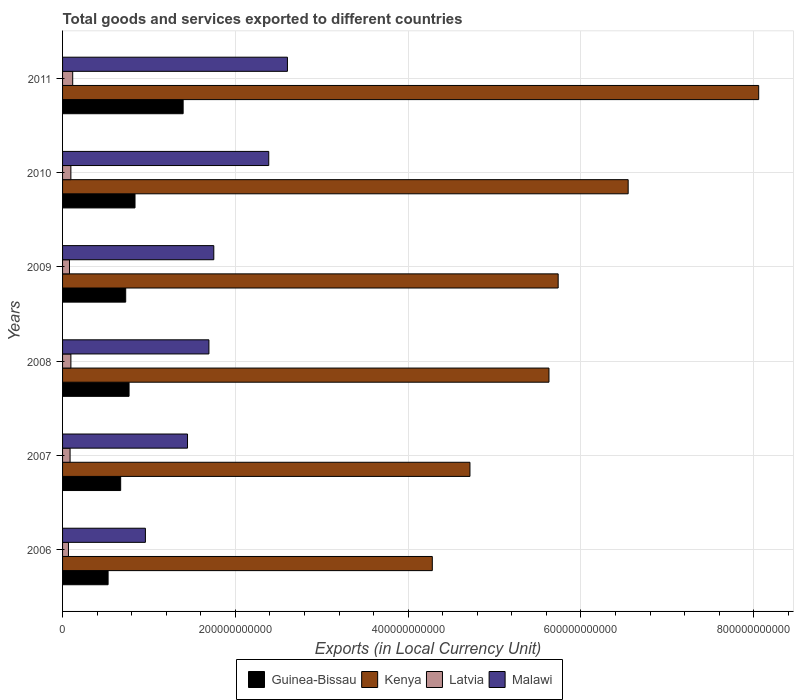How many different coloured bars are there?
Offer a very short reply. 4. Are the number of bars per tick equal to the number of legend labels?
Offer a very short reply. Yes. What is the label of the 1st group of bars from the top?
Your answer should be very brief. 2011. In how many cases, is the number of bars for a given year not equal to the number of legend labels?
Your response must be concise. 0. What is the Amount of goods and services exports in Latvia in 2006?
Offer a very short reply. 6.84e+09. Across all years, what is the maximum Amount of goods and services exports in Kenya?
Ensure brevity in your answer.  8.06e+11. Across all years, what is the minimum Amount of goods and services exports in Kenya?
Give a very brief answer. 4.28e+11. In which year was the Amount of goods and services exports in Latvia maximum?
Offer a terse response. 2011. In which year was the Amount of goods and services exports in Guinea-Bissau minimum?
Make the answer very short. 2006. What is the total Amount of goods and services exports in Kenya in the graph?
Keep it short and to the point. 3.50e+12. What is the difference between the Amount of goods and services exports in Latvia in 2007 and that in 2009?
Provide a succinct answer. 6.66e+08. What is the difference between the Amount of goods and services exports in Malawi in 2006 and the Amount of goods and services exports in Kenya in 2009?
Make the answer very short. -4.78e+11. What is the average Amount of goods and services exports in Malawi per year?
Offer a very short reply. 1.81e+11. In the year 2011, what is the difference between the Amount of goods and services exports in Guinea-Bissau and Amount of goods and services exports in Latvia?
Provide a short and direct response. 1.28e+11. In how many years, is the Amount of goods and services exports in Guinea-Bissau greater than 760000000000 LCU?
Offer a very short reply. 0. What is the ratio of the Amount of goods and services exports in Malawi in 2006 to that in 2011?
Keep it short and to the point. 0.37. Is the Amount of goods and services exports in Malawi in 2007 less than that in 2010?
Your answer should be very brief. Yes. Is the difference between the Amount of goods and services exports in Guinea-Bissau in 2007 and 2009 greater than the difference between the Amount of goods and services exports in Latvia in 2007 and 2009?
Your answer should be compact. No. What is the difference between the highest and the second highest Amount of goods and services exports in Guinea-Bissau?
Provide a short and direct response. 5.57e+1. What is the difference between the highest and the lowest Amount of goods and services exports in Malawi?
Your response must be concise. 1.64e+11. Is the sum of the Amount of goods and services exports in Kenya in 2007 and 2011 greater than the maximum Amount of goods and services exports in Latvia across all years?
Offer a terse response. Yes. What does the 1st bar from the top in 2009 represents?
Provide a succinct answer. Malawi. What does the 3rd bar from the bottom in 2007 represents?
Give a very brief answer. Latvia. Is it the case that in every year, the sum of the Amount of goods and services exports in Malawi and Amount of goods and services exports in Guinea-Bissau is greater than the Amount of goods and services exports in Kenya?
Your answer should be compact. No. Are all the bars in the graph horizontal?
Make the answer very short. Yes. How many years are there in the graph?
Your answer should be compact. 6. What is the difference between two consecutive major ticks on the X-axis?
Make the answer very short. 2.00e+11. Are the values on the major ticks of X-axis written in scientific E-notation?
Keep it short and to the point. No. Where does the legend appear in the graph?
Offer a terse response. Bottom center. How many legend labels are there?
Your answer should be very brief. 4. What is the title of the graph?
Ensure brevity in your answer.  Total goods and services exported to different countries. Does "Pakistan" appear as one of the legend labels in the graph?
Your answer should be compact. No. What is the label or title of the X-axis?
Provide a succinct answer. Exports (in Local Currency Unit). What is the Exports (in Local Currency Unit) in Guinea-Bissau in 2006?
Your answer should be compact. 5.27e+1. What is the Exports (in Local Currency Unit) of Kenya in 2006?
Ensure brevity in your answer.  4.28e+11. What is the Exports (in Local Currency Unit) of Latvia in 2006?
Keep it short and to the point. 6.84e+09. What is the Exports (in Local Currency Unit) of Malawi in 2006?
Ensure brevity in your answer.  9.59e+1. What is the Exports (in Local Currency Unit) in Guinea-Bissau in 2007?
Offer a very short reply. 6.73e+1. What is the Exports (in Local Currency Unit) of Kenya in 2007?
Your answer should be compact. 4.72e+11. What is the Exports (in Local Currency Unit) of Latvia in 2007?
Your answer should be very brief. 8.69e+09. What is the Exports (in Local Currency Unit) of Malawi in 2007?
Your response must be concise. 1.45e+11. What is the Exports (in Local Currency Unit) of Guinea-Bissau in 2008?
Make the answer very short. 7.70e+1. What is the Exports (in Local Currency Unit) in Kenya in 2008?
Provide a succinct answer. 5.63e+11. What is the Exports (in Local Currency Unit) of Latvia in 2008?
Make the answer very short. 9.63e+09. What is the Exports (in Local Currency Unit) in Malawi in 2008?
Ensure brevity in your answer.  1.69e+11. What is the Exports (in Local Currency Unit) in Guinea-Bissau in 2009?
Your answer should be compact. 7.31e+1. What is the Exports (in Local Currency Unit) in Kenya in 2009?
Your response must be concise. 5.74e+11. What is the Exports (in Local Currency Unit) of Latvia in 2009?
Your response must be concise. 8.02e+09. What is the Exports (in Local Currency Unit) in Malawi in 2009?
Offer a terse response. 1.75e+11. What is the Exports (in Local Currency Unit) in Guinea-Bissau in 2010?
Your response must be concise. 8.39e+1. What is the Exports (in Local Currency Unit) of Kenya in 2010?
Keep it short and to the point. 6.55e+11. What is the Exports (in Local Currency Unit) in Latvia in 2010?
Offer a very short reply. 9.62e+09. What is the Exports (in Local Currency Unit) in Malawi in 2010?
Offer a very short reply. 2.39e+11. What is the Exports (in Local Currency Unit) in Guinea-Bissau in 2011?
Offer a very short reply. 1.40e+11. What is the Exports (in Local Currency Unit) in Kenya in 2011?
Your answer should be compact. 8.06e+11. What is the Exports (in Local Currency Unit) of Latvia in 2011?
Make the answer very short. 1.17e+1. What is the Exports (in Local Currency Unit) in Malawi in 2011?
Make the answer very short. 2.60e+11. Across all years, what is the maximum Exports (in Local Currency Unit) in Guinea-Bissau?
Provide a short and direct response. 1.40e+11. Across all years, what is the maximum Exports (in Local Currency Unit) in Kenya?
Keep it short and to the point. 8.06e+11. Across all years, what is the maximum Exports (in Local Currency Unit) in Latvia?
Give a very brief answer. 1.17e+1. Across all years, what is the maximum Exports (in Local Currency Unit) of Malawi?
Your answer should be very brief. 2.60e+11. Across all years, what is the minimum Exports (in Local Currency Unit) in Guinea-Bissau?
Keep it short and to the point. 5.27e+1. Across all years, what is the minimum Exports (in Local Currency Unit) of Kenya?
Provide a short and direct response. 4.28e+11. Across all years, what is the minimum Exports (in Local Currency Unit) of Latvia?
Provide a short and direct response. 6.84e+09. Across all years, what is the minimum Exports (in Local Currency Unit) in Malawi?
Offer a terse response. 9.59e+1. What is the total Exports (in Local Currency Unit) of Guinea-Bissau in the graph?
Your answer should be compact. 4.93e+11. What is the total Exports (in Local Currency Unit) in Kenya in the graph?
Your answer should be compact. 3.50e+12. What is the total Exports (in Local Currency Unit) in Latvia in the graph?
Your answer should be very brief. 5.45e+1. What is the total Exports (in Local Currency Unit) of Malawi in the graph?
Keep it short and to the point. 1.08e+12. What is the difference between the Exports (in Local Currency Unit) of Guinea-Bissau in 2006 and that in 2007?
Your answer should be very brief. -1.46e+1. What is the difference between the Exports (in Local Currency Unit) of Kenya in 2006 and that in 2007?
Ensure brevity in your answer.  -4.36e+1. What is the difference between the Exports (in Local Currency Unit) of Latvia in 2006 and that in 2007?
Provide a succinct answer. -1.85e+09. What is the difference between the Exports (in Local Currency Unit) in Malawi in 2006 and that in 2007?
Your response must be concise. -4.87e+1. What is the difference between the Exports (in Local Currency Unit) of Guinea-Bissau in 2006 and that in 2008?
Provide a succinct answer. -2.43e+1. What is the difference between the Exports (in Local Currency Unit) of Kenya in 2006 and that in 2008?
Provide a succinct answer. -1.35e+11. What is the difference between the Exports (in Local Currency Unit) of Latvia in 2006 and that in 2008?
Your answer should be compact. -2.79e+09. What is the difference between the Exports (in Local Currency Unit) in Malawi in 2006 and that in 2008?
Keep it short and to the point. -7.35e+1. What is the difference between the Exports (in Local Currency Unit) in Guinea-Bissau in 2006 and that in 2009?
Your answer should be very brief. -2.04e+1. What is the difference between the Exports (in Local Currency Unit) of Kenya in 2006 and that in 2009?
Offer a very short reply. -1.46e+11. What is the difference between the Exports (in Local Currency Unit) of Latvia in 2006 and that in 2009?
Provide a succinct answer. -1.18e+09. What is the difference between the Exports (in Local Currency Unit) in Malawi in 2006 and that in 2009?
Offer a terse response. -7.92e+1. What is the difference between the Exports (in Local Currency Unit) of Guinea-Bissau in 2006 and that in 2010?
Offer a terse response. -3.12e+1. What is the difference between the Exports (in Local Currency Unit) in Kenya in 2006 and that in 2010?
Keep it short and to the point. -2.27e+11. What is the difference between the Exports (in Local Currency Unit) in Latvia in 2006 and that in 2010?
Offer a terse response. -2.79e+09. What is the difference between the Exports (in Local Currency Unit) of Malawi in 2006 and that in 2010?
Provide a succinct answer. -1.43e+11. What is the difference between the Exports (in Local Currency Unit) of Guinea-Bissau in 2006 and that in 2011?
Offer a terse response. -8.69e+1. What is the difference between the Exports (in Local Currency Unit) in Kenya in 2006 and that in 2011?
Offer a terse response. -3.78e+11. What is the difference between the Exports (in Local Currency Unit) of Latvia in 2006 and that in 2011?
Ensure brevity in your answer.  -4.90e+09. What is the difference between the Exports (in Local Currency Unit) in Malawi in 2006 and that in 2011?
Ensure brevity in your answer.  -1.64e+11. What is the difference between the Exports (in Local Currency Unit) in Guinea-Bissau in 2007 and that in 2008?
Give a very brief answer. -9.71e+09. What is the difference between the Exports (in Local Currency Unit) of Kenya in 2007 and that in 2008?
Provide a short and direct response. -9.15e+1. What is the difference between the Exports (in Local Currency Unit) of Latvia in 2007 and that in 2008?
Keep it short and to the point. -9.42e+08. What is the difference between the Exports (in Local Currency Unit) in Malawi in 2007 and that in 2008?
Your answer should be very brief. -2.48e+1. What is the difference between the Exports (in Local Currency Unit) in Guinea-Bissau in 2007 and that in 2009?
Provide a succinct answer. -5.81e+09. What is the difference between the Exports (in Local Currency Unit) of Kenya in 2007 and that in 2009?
Make the answer very short. -1.02e+11. What is the difference between the Exports (in Local Currency Unit) in Latvia in 2007 and that in 2009?
Make the answer very short. 6.66e+08. What is the difference between the Exports (in Local Currency Unit) of Malawi in 2007 and that in 2009?
Ensure brevity in your answer.  -3.04e+1. What is the difference between the Exports (in Local Currency Unit) in Guinea-Bissau in 2007 and that in 2010?
Your answer should be compact. -1.66e+1. What is the difference between the Exports (in Local Currency Unit) in Kenya in 2007 and that in 2010?
Provide a succinct answer. -1.83e+11. What is the difference between the Exports (in Local Currency Unit) of Latvia in 2007 and that in 2010?
Give a very brief answer. -9.38e+08. What is the difference between the Exports (in Local Currency Unit) of Malawi in 2007 and that in 2010?
Ensure brevity in your answer.  -9.40e+1. What is the difference between the Exports (in Local Currency Unit) of Guinea-Bissau in 2007 and that in 2011?
Keep it short and to the point. -7.23e+1. What is the difference between the Exports (in Local Currency Unit) of Kenya in 2007 and that in 2011?
Provide a short and direct response. -3.34e+11. What is the difference between the Exports (in Local Currency Unit) in Latvia in 2007 and that in 2011?
Offer a terse response. -3.05e+09. What is the difference between the Exports (in Local Currency Unit) of Malawi in 2007 and that in 2011?
Offer a very short reply. -1.16e+11. What is the difference between the Exports (in Local Currency Unit) in Guinea-Bissau in 2008 and that in 2009?
Keep it short and to the point. 3.90e+09. What is the difference between the Exports (in Local Currency Unit) in Kenya in 2008 and that in 2009?
Your response must be concise. -1.07e+1. What is the difference between the Exports (in Local Currency Unit) in Latvia in 2008 and that in 2009?
Your answer should be very brief. 1.61e+09. What is the difference between the Exports (in Local Currency Unit) of Malawi in 2008 and that in 2009?
Provide a succinct answer. -5.64e+09. What is the difference between the Exports (in Local Currency Unit) in Guinea-Bissau in 2008 and that in 2010?
Provide a short and direct response. -6.88e+09. What is the difference between the Exports (in Local Currency Unit) of Kenya in 2008 and that in 2010?
Offer a terse response. -9.17e+1. What is the difference between the Exports (in Local Currency Unit) in Latvia in 2008 and that in 2010?
Your answer should be very brief. 4.06e+06. What is the difference between the Exports (in Local Currency Unit) of Malawi in 2008 and that in 2010?
Your answer should be very brief. -6.92e+1. What is the difference between the Exports (in Local Currency Unit) in Guinea-Bissau in 2008 and that in 2011?
Ensure brevity in your answer.  -6.26e+1. What is the difference between the Exports (in Local Currency Unit) in Kenya in 2008 and that in 2011?
Give a very brief answer. -2.43e+11. What is the difference between the Exports (in Local Currency Unit) of Latvia in 2008 and that in 2011?
Give a very brief answer. -2.11e+09. What is the difference between the Exports (in Local Currency Unit) in Malawi in 2008 and that in 2011?
Give a very brief answer. -9.09e+1. What is the difference between the Exports (in Local Currency Unit) of Guinea-Bissau in 2009 and that in 2010?
Keep it short and to the point. -1.08e+1. What is the difference between the Exports (in Local Currency Unit) of Kenya in 2009 and that in 2010?
Your answer should be very brief. -8.10e+1. What is the difference between the Exports (in Local Currency Unit) in Latvia in 2009 and that in 2010?
Offer a terse response. -1.60e+09. What is the difference between the Exports (in Local Currency Unit) in Malawi in 2009 and that in 2010?
Give a very brief answer. -6.36e+1. What is the difference between the Exports (in Local Currency Unit) in Guinea-Bissau in 2009 and that in 2011?
Provide a succinct answer. -6.65e+1. What is the difference between the Exports (in Local Currency Unit) in Kenya in 2009 and that in 2011?
Give a very brief answer. -2.32e+11. What is the difference between the Exports (in Local Currency Unit) of Latvia in 2009 and that in 2011?
Provide a short and direct response. -3.72e+09. What is the difference between the Exports (in Local Currency Unit) in Malawi in 2009 and that in 2011?
Provide a short and direct response. -8.52e+1. What is the difference between the Exports (in Local Currency Unit) in Guinea-Bissau in 2010 and that in 2011?
Ensure brevity in your answer.  -5.57e+1. What is the difference between the Exports (in Local Currency Unit) of Kenya in 2010 and that in 2011?
Give a very brief answer. -1.51e+11. What is the difference between the Exports (in Local Currency Unit) of Latvia in 2010 and that in 2011?
Your answer should be compact. -2.11e+09. What is the difference between the Exports (in Local Currency Unit) of Malawi in 2010 and that in 2011?
Offer a very short reply. -2.16e+1. What is the difference between the Exports (in Local Currency Unit) of Guinea-Bissau in 2006 and the Exports (in Local Currency Unit) of Kenya in 2007?
Offer a terse response. -4.19e+11. What is the difference between the Exports (in Local Currency Unit) in Guinea-Bissau in 2006 and the Exports (in Local Currency Unit) in Latvia in 2007?
Offer a very short reply. 4.40e+1. What is the difference between the Exports (in Local Currency Unit) of Guinea-Bissau in 2006 and the Exports (in Local Currency Unit) of Malawi in 2007?
Ensure brevity in your answer.  -9.19e+1. What is the difference between the Exports (in Local Currency Unit) of Kenya in 2006 and the Exports (in Local Currency Unit) of Latvia in 2007?
Make the answer very short. 4.19e+11. What is the difference between the Exports (in Local Currency Unit) in Kenya in 2006 and the Exports (in Local Currency Unit) in Malawi in 2007?
Provide a short and direct response. 2.83e+11. What is the difference between the Exports (in Local Currency Unit) of Latvia in 2006 and the Exports (in Local Currency Unit) of Malawi in 2007?
Your answer should be compact. -1.38e+11. What is the difference between the Exports (in Local Currency Unit) in Guinea-Bissau in 2006 and the Exports (in Local Currency Unit) in Kenya in 2008?
Offer a terse response. -5.10e+11. What is the difference between the Exports (in Local Currency Unit) of Guinea-Bissau in 2006 and the Exports (in Local Currency Unit) of Latvia in 2008?
Offer a terse response. 4.31e+1. What is the difference between the Exports (in Local Currency Unit) in Guinea-Bissau in 2006 and the Exports (in Local Currency Unit) in Malawi in 2008?
Give a very brief answer. -1.17e+11. What is the difference between the Exports (in Local Currency Unit) of Kenya in 2006 and the Exports (in Local Currency Unit) of Latvia in 2008?
Your answer should be very brief. 4.18e+11. What is the difference between the Exports (in Local Currency Unit) in Kenya in 2006 and the Exports (in Local Currency Unit) in Malawi in 2008?
Ensure brevity in your answer.  2.59e+11. What is the difference between the Exports (in Local Currency Unit) of Latvia in 2006 and the Exports (in Local Currency Unit) of Malawi in 2008?
Ensure brevity in your answer.  -1.63e+11. What is the difference between the Exports (in Local Currency Unit) of Guinea-Bissau in 2006 and the Exports (in Local Currency Unit) of Kenya in 2009?
Provide a succinct answer. -5.21e+11. What is the difference between the Exports (in Local Currency Unit) in Guinea-Bissau in 2006 and the Exports (in Local Currency Unit) in Latvia in 2009?
Your response must be concise. 4.47e+1. What is the difference between the Exports (in Local Currency Unit) of Guinea-Bissau in 2006 and the Exports (in Local Currency Unit) of Malawi in 2009?
Provide a succinct answer. -1.22e+11. What is the difference between the Exports (in Local Currency Unit) in Kenya in 2006 and the Exports (in Local Currency Unit) in Latvia in 2009?
Offer a very short reply. 4.20e+11. What is the difference between the Exports (in Local Currency Unit) in Kenya in 2006 and the Exports (in Local Currency Unit) in Malawi in 2009?
Give a very brief answer. 2.53e+11. What is the difference between the Exports (in Local Currency Unit) in Latvia in 2006 and the Exports (in Local Currency Unit) in Malawi in 2009?
Give a very brief answer. -1.68e+11. What is the difference between the Exports (in Local Currency Unit) of Guinea-Bissau in 2006 and the Exports (in Local Currency Unit) of Kenya in 2010?
Your response must be concise. -6.02e+11. What is the difference between the Exports (in Local Currency Unit) of Guinea-Bissau in 2006 and the Exports (in Local Currency Unit) of Latvia in 2010?
Provide a short and direct response. 4.31e+1. What is the difference between the Exports (in Local Currency Unit) of Guinea-Bissau in 2006 and the Exports (in Local Currency Unit) of Malawi in 2010?
Ensure brevity in your answer.  -1.86e+11. What is the difference between the Exports (in Local Currency Unit) in Kenya in 2006 and the Exports (in Local Currency Unit) in Latvia in 2010?
Ensure brevity in your answer.  4.18e+11. What is the difference between the Exports (in Local Currency Unit) in Kenya in 2006 and the Exports (in Local Currency Unit) in Malawi in 2010?
Ensure brevity in your answer.  1.89e+11. What is the difference between the Exports (in Local Currency Unit) in Latvia in 2006 and the Exports (in Local Currency Unit) in Malawi in 2010?
Your answer should be very brief. -2.32e+11. What is the difference between the Exports (in Local Currency Unit) in Guinea-Bissau in 2006 and the Exports (in Local Currency Unit) in Kenya in 2011?
Ensure brevity in your answer.  -7.53e+11. What is the difference between the Exports (in Local Currency Unit) in Guinea-Bissau in 2006 and the Exports (in Local Currency Unit) in Latvia in 2011?
Ensure brevity in your answer.  4.10e+1. What is the difference between the Exports (in Local Currency Unit) in Guinea-Bissau in 2006 and the Exports (in Local Currency Unit) in Malawi in 2011?
Ensure brevity in your answer.  -2.08e+11. What is the difference between the Exports (in Local Currency Unit) in Kenya in 2006 and the Exports (in Local Currency Unit) in Latvia in 2011?
Provide a short and direct response. 4.16e+11. What is the difference between the Exports (in Local Currency Unit) in Kenya in 2006 and the Exports (in Local Currency Unit) in Malawi in 2011?
Keep it short and to the point. 1.68e+11. What is the difference between the Exports (in Local Currency Unit) in Latvia in 2006 and the Exports (in Local Currency Unit) in Malawi in 2011?
Keep it short and to the point. -2.53e+11. What is the difference between the Exports (in Local Currency Unit) of Guinea-Bissau in 2007 and the Exports (in Local Currency Unit) of Kenya in 2008?
Your response must be concise. -4.96e+11. What is the difference between the Exports (in Local Currency Unit) in Guinea-Bissau in 2007 and the Exports (in Local Currency Unit) in Latvia in 2008?
Your answer should be compact. 5.76e+1. What is the difference between the Exports (in Local Currency Unit) in Guinea-Bissau in 2007 and the Exports (in Local Currency Unit) in Malawi in 2008?
Offer a terse response. -1.02e+11. What is the difference between the Exports (in Local Currency Unit) of Kenya in 2007 and the Exports (in Local Currency Unit) of Latvia in 2008?
Ensure brevity in your answer.  4.62e+11. What is the difference between the Exports (in Local Currency Unit) in Kenya in 2007 and the Exports (in Local Currency Unit) in Malawi in 2008?
Give a very brief answer. 3.02e+11. What is the difference between the Exports (in Local Currency Unit) of Latvia in 2007 and the Exports (in Local Currency Unit) of Malawi in 2008?
Your response must be concise. -1.61e+11. What is the difference between the Exports (in Local Currency Unit) of Guinea-Bissau in 2007 and the Exports (in Local Currency Unit) of Kenya in 2009?
Your answer should be compact. -5.06e+11. What is the difference between the Exports (in Local Currency Unit) of Guinea-Bissau in 2007 and the Exports (in Local Currency Unit) of Latvia in 2009?
Your answer should be very brief. 5.92e+1. What is the difference between the Exports (in Local Currency Unit) of Guinea-Bissau in 2007 and the Exports (in Local Currency Unit) of Malawi in 2009?
Give a very brief answer. -1.08e+11. What is the difference between the Exports (in Local Currency Unit) of Kenya in 2007 and the Exports (in Local Currency Unit) of Latvia in 2009?
Keep it short and to the point. 4.64e+11. What is the difference between the Exports (in Local Currency Unit) in Kenya in 2007 and the Exports (in Local Currency Unit) in Malawi in 2009?
Offer a terse response. 2.97e+11. What is the difference between the Exports (in Local Currency Unit) in Latvia in 2007 and the Exports (in Local Currency Unit) in Malawi in 2009?
Ensure brevity in your answer.  -1.66e+11. What is the difference between the Exports (in Local Currency Unit) of Guinea-Bissau in 2007 and the Exports (in Local Currency Unit) of Kenya in 2010?
Your response must be concise. -5.87e+11. What is the difference between the Exports (in Local Currency Unit) of Guinea-Bissau in 2007 and the Exports (in Local Currency Unit) of Latvia in 2010?
Your answer should be very brief. 5.76e+1. What is the difference between the Exports (in Local Currency Unit) of Guinea-Bissau in 2007 and the Exports (in Local Currency Unit) of Malawi in 2010?
Make the answer very short. -1.71e+11. What is the difference between the Exports (in Local Currency Unit) of Kenya in 2007 and the Exports (in Local Currency Unit) of Latvia in 2010?
Your response must be concise. 4.62e+11. What is the difference between the Exports (in Local Currency Unit) of Kenya in 2007 and the Exports (in Local Currency Unit) of Malawi in 2010?
Offer a terse response. 2.33e+11. What is the difference between the Exports (in Local Currency Unit) in Latvia in 2007 and the Exports (in Local Currency Unit) in Malawi in 2010?
Your response must be concise. -2.30e+11. What is the difference between the Exports (in Local Currency Unit) in Guinea-Bissau in 2007 and the Exports (in Local Currency Unit) in Kenya in 2011?
Keep it short and to the point. -7.38e+11. What is the difference between the Exports (in Local Currency Unit) of Guinea-Bissau in 2007 and the Exports (in Local Currency Unit) of Latvia in 2011?
Give a very brief answer. 5.55e+1. What is the difference between the Exports (in Local Currency Unit) in Guinea-Bissau in 2007 and the Exports (in Local Currency Unit) in Malawi in 2011?
Offer a very short reply. -1.93e+11. What is the difference between the Exports (in Local Currency Unit) of Kenya in 2007 and the Exports (in Local Currency Unit) of Latvia in 2011?
Your answer should be compact. 4.60e+11. What is the difference between the Exports (in Local Currency Unit) of Kenya in 2007 and the Exports (in Local Currency Unit) of Malawi in 2011?
Your answer should be compact. 2.11e+11. What is the difference between the Exports (in Local Currency Unit) of Latvia in 2007 and the Exports (in Local Currency Unit) of Malawi in 2011?
Offer a terse response. -2.52e+11. What is the difference between the Exports (in Local Currency Unit) of Guinea-Bissau in 2008 and the Exports (in Local Currency Unit) of Kenya in 2009?
Keep it short and to the point. -4.97e+11. What is the difference between the Exports (in Local Currency Unit) in Guinea-Bissau in 2008 and the Exports (in Local Currency Unit) in Latvia in 2009?
Give a very brief answer. 6.90e+1. What is the difference between the Exports (in Local Currency Unit) of Guinea-Bissau in 2008 and the Exports (in Local Currency Unit) of Malawi in 2009?
Ensure brevity in your answer.  -9.81e+1. What is the difference between the Exports (in Local Currency Unit) in Kenya in 2008 and the Exports (in Local Currency Unit) in Latvia in 2009?
Provide a short and direct response. 5.55e+11. What is the difference between the Exports (in Local Currency Unit) of Kenya in 2008 and the Exports (in Local Currency Unit) of Malawi in 2009?
Give a very brief answer. 3.88e+11. What is the difference between the Exports (in Local Currency Unit) in Latvia in 2008 and the Exports (in Local Currency Unit) in Malawi in 2009?
Provide a short and direct response. -1.65e+11. What is the difference between the Exports (in Local Currency Unit) of Guinea-Bissau in 2008 and the Exports (in Local Currency Unit) of Kenya in 2010?
Offer a terse response. -5.78e+11. What is the difference between the Exports (in Local Currency Unit) in Guinea-Bissau in 2008 and the Exports (in Local Currency Unit) in Latvia in 2010?
Keep it short and to the point. 6.74e+1. What is the difference between the Exports (in Local Currency Unit) of Guinea-Bissau in 2008 and the Exports (in Local Currency Unit) of Malawi in 2010?
Give a very brief answer. -1.62e+11. What is the difference between the Exports (in Local Currency Unit) in Kenya in 2008 and the Exports (in Local Currency Unit) in Latvia in 2010?
Offer a very short reply. 5.53e+11. What is the difference between the Exports (in Local Currency Unit) of Kenya in 2008 and the Exports (in Local Currency Unit) of Malawi in 2010?
Give a very brief answer. 3.24e+11. What is the difference between the Exports (in Local Currency Unit) of Latvia in 2008 and the Exports (in Local Currency Unit) of Malawi in 2010?
Provide a succinct answer. -2.29e+11. What is the difference between the Exports (in Local Currency Unit) of Guinea-Bissau in 2008 and the Exports (in Local Currency Unit) of Kenya in 2011?
Your answer should be compact. -7.29e+11. What is the difference between the Exports (in Local Currency Unit) of Guinea-Bissau in 2008 and the Exports (in Local Currency Unit) of Latvia in 2011?
Ensure brevity in your answer.  6.52e+1. What is the difference between the Exports (in Local Currency Unit) in Guinea-Bissau in 2008 and the Exports (in Local Currency Unit) in Malawi in 2011?
Your answer should be very brief. -1.83e+11. What is the difference between the Exports (in Local Currency Unit) of Kenya in 2008 and the Exports (in Local Currency Unit) of Latvia in 2011?
Keep it short and to the point. 5.51e+11. What is the difference between the Exports (in Local Currency Unit) in Kenya in 2008 and the Exports (in Local Currency Unit) in Malawi in 2011?
Keep it short and to the point. 3.03e+11. What is the difference between the Exports (in Local Currency Unit) in Latvia in 2008 and the Exports (in Local Currency Unit) in Malawi in 2011?
Ensure brevity in your answer.  -2.51e+11. What is the difference between the Exports (in Local Currency Unit) in Guinea-Bissau in 2009 and the Exports (in Local Currency Unit) in Kenya in 2010?
Provide a succinct answer. -5.82e+11. What is the difference between the Exports (in Local Currency Unit) in Guinea-Bissau in 2009 and the Exports (in Local Currency Unit) in Latvia in 2010?
Make the answer very short. 6.34e+1. What is the difference between the Exports (in Local Currency Unit) in Guinea-Bissau in 2009 and the Exports (in Local Currency Unit) in Malawi in 2010?
Offer a very short reply. -1.66e+11. What is the difference between the Exports (in Local Currency Unit) in Kenya in 2009 and the Exports (in Local Currency Unit) in Latvia in 2010?
Ensure brevity in your answer.  5.64e+11. What is the difference between the Exports (in Local Currency Unit) of Kenya in 2009 and the Exports (in Local Currency Unit) of Malawi in 2010?
Make the answer very short. 3.35e+11. What is the difference between the Exports (in Local Currency Unit) in Latvia in 2009 and the Exports (in Local Currency Unit) in Malawi in 2010?
Your response must be concise. -2.31e+11. What is the difference between the Exports (in Local Currency Unit) of Guinea-Bissau in 2009 and the Exports (in Local Currency Unit) of Kenya in 2011?
Provide a short and direct response. -7.33e+11. What is the difference between the Exports (in Local Currency Unit) of Guinea-Bissau in 2009 and the Exports (in Local Currency Unit) of Latvia in 2011?
Offer a very short reply. 6.13e+1. What is the difference between the Exports (in Local Currency Unit) in Guinea-Bissau in 2009 and the Exports (in Local Currency Unit) in Malawi in 2011?
Give a very brief answer. -1.87e+11. What is the difference between the Exports (in Local Currency Unit) of Kenya in 2009 and the Exports (in Local Currency Unit) of Latvia in 2011?
Provide a succinct answer. 5.62e+11. What is the difference between the Exports (in Local Currency Unit) of Kenya in 2009 and the Exports (in Local Currency Unit) of Malawi in 2011?
Your answer should be compact. 3.13e+11. What is the difference between the Exports (in Local Currency Unit) of Latvia in 2009 and the Exports (in Local Currency Unit) of Malawi in 2011?
Offer a very short reply. -2.52e+11. What is the difference between the Exports (in Local Currency Unit) in Guinea-Bissau in 2010 and the Exports (in Local Currency Unit) in Kenya in 2011?
Offer a very short reply. -7.22e+11. What is the difference between the Exports (in Local Currency Unit) of Guinea-Bissau in 2010 and the Exports (in Local Currency Unit) of Latvia in 2011?
Provide a succinct answer. 7.21e+1. What is the difference between the Exports (in Local Currency Unit) in Guinea-Bissau in 2010 and the Exports (in Local Currency Unit) in Malawi in 2011?
Your answer should be compact. -1.76e+11. What is the difference between the Exports (in Local Currency Unit) in Kenya in 2010 and the Exports (in Local Currency Unit) in Latvia in 2011?
Offer a very short reply. 6.43e+11. What is the difference between the Exports (in Local Currency Unit) of Kenya in 2010 and the Exports (in Local Currency Unit) of Malawi in 2011?
Provide a succinct answer. 3.94e+11. What is the difference between the Exports (in Local Currency Unit) in Latvia in 2010 and the Exports (in Local Currency Unit) in Malawi in 2011?
Ensure brevity in your answer.  -2.51e+11. What is the average Exports (in Local Currency Unit) in Guinea-Bissau per year?
Make the answer very short. 8.22e+1. What is the average Exports (in Local Currency Unit) of Kenya per year?
Keep it short and to the point. 5.83e+11. What is the average Exports (in Local Currency Unit) in Latvia per year?
Your answer should be compact. 9.09e+09. What is the average Exports (in Local Currency Unit) in Malawi per year?
Provide a succinct answer. 1.81e+11. In the year 2006, what is the difference between the Exports (in Local Currency Unit) of Guinea-Bissau and Exports (in Local Currency Unit) of Kenya?
Your answer should be compact. -3.75e+11. In the year 2006, what is the difference between the Exports (in Local Currency Unit) in Guinea-Bissau and Exports (in Local Currency Unit) in Latvia?
Give a very brief answer. 4.59e+1. In the year 2006, what is the difference between the Exports (in Local Currency Unit) in Guinea-Bissau and Exports (in Local Currency Unit) in Malawi?
Offer a terse response. -4.32e+1. In the year 2006, what is the difference between the Exports (in Local Currency Unit) in Kenya and Exports (in Local Currency Unit) in Latvia?
Offer a terse response. 4.21e+11. In the year 2006, what is the difference between the Exports (in Local Currency Unit) in Kenya and Exports (in Local Currency Unit) in Malawi?
Keep it short and to the point. 3.32e+11. In the year 2006, what is the difference between the Exports (in Local Currency Unit) of Latvia and Exports (in Local Currency Unit) of Malawi?
Keep it short and to the point. -8.91e+1. In the year 2007, what is the difference between the Exports (in Local Currency Unit) of Guinea-Bissau and Exports (in Local Currency Unit) of Kenya?
Your answer should be very brief. -4.04e+11. In the year 2007, what is the difference between the Exports (in Local Currency Unit) in Guinea-Bissau and Exports (in Local Currency Unit) in Latvia?
Your answer should be compact. 5.86e+1. In the year 2007, what is the difference between the Exports (in Local Currency Unit) in Guinea-Bissau and Exports (in Local Currency Unit) in Malawi?
Your answer should be compact. -7.74e+1. In the year 2007, what is the difference between the Exports (in Local Currency Unit) of Kenya and Exports (in Local Currency Unit) of Latvia?
Your response must be concise. 4.63e+11. In the year 2007, what is the difference between the Exports (in Local Currency Unit) of Kenya and Exports (in Local Currency Unit) of Malawi?
Keep it short and to the point. 3.27e+11. In the year 2007, what is the difference between the Exports (in Local Currency Unit) in Latvia and Exports (in Local Currency Unit) in Malawi?
Give a very brief answer. -1.36e+11. In the year 2008, what is the difference between the Exports (in Local Currency Unit) in Guinea-Bissau and Exports (in Local Currency Unit) in Kenya?
Offer a terse response. -4.86e+11. In the year 2008, what is the difference between the Exports (in Local Currency Unit) of Guinea-Bissau and Exports (in Local Currency Unit) of Latvia?
Provide a succinct answer. 6.73e+1. In the year 2008, what is the difference between the Exports (in Local Currency Unit) of Guinea-Bissau and Exports (in Local Currency Unit) of Malawi?
Keep it short and to the point. -9.24e+1. In the year 2008, what is the difference between the Exports (in Local Currency Unit) in Kenya and Exports (in Local Currency Unit) in Latvia?
Provide a short and direct response. 5.53e+11. In the year 2008, what is the difference between the Exports (in Local Currency Unit) in Kenya and Exports (in Local Currency Unit) in Malawi?
Your answer should be very brief. 3.94e+11. In the year 2008, what is the difference between the Exports (in Local Currency Unit) of Latvia and Exports (in Local Currency Unit) of Malawi?
Your response must be concise. -1.60e+11. In the year 2009, what is the difference between the Exports (in Local Currency Unit) of Guinea-Bissau and Exports (in Local Currency Unit) of Kenya?
Ensure brevity in your answer.  -5.01e+11. In the year 2009, what is the difference between the Exports (in Local Currency Unit) of Guinea-Bissau and Exports (in Local Currency Unit) of Latvia?
Your response must be concise. 6.51e+1. In the year 2009, what is the difference between the Exports (in Local Currency Unit) of Guinea-Bissau and Exports (in Local Currency Unit) of Malawi?
Provide a short and direct response. -1.02e+11. In the year 2009, what is the difference between the Exports (in Local Currency Unit) of Kenya and Exports (in Local Currency Unit) of Latvia?
Make the answer very short. 5.66e+11. In the year 2009, what is the difference between the Exports (in Local Currency Unit) in Kenya and Exports (in Local Currency Unit) in Malawi?
Offer a very short reply. 3.99e+11. In the year 2009, what is the difference between the Exports (in Local Currency Unit) of Latvia and Exports (in Local Currency Unit) of Malawi?
Ensure brevity in your answer.  -1.67e+11. In the year 2010, what is the difference between the Exports (in Local Currency Unit) in Guinea-Bissau and Exports (in Local Currency Unit) in Kenya?
Offer a terse response. -5.71e+11. In the year 2010, what is the difference between the Exports (in Local Currency Unit) in Guinea-Bissau and Exports (in Local Currency Unit) in Latvia?
Your response must be concise. 7.42e+1. In the year 2010, what is the difference between the Exports (in Local Currency Unit) of Guinea-Bissau and Exports (in Local Currency Unit) of Malawi?
Provide a succinct answer. -1.55e+11. In the year 2010, what is the difference between the Exports (in Local Currency Unit) in Kenya and Exports (in Local Currency Unit) in Latvia?
Keep it short and to the point. 6.45e+11. In the year 2010, what is the difference between the Exports (in Local Currency Unit) in Kenya and Exports (in Local Currency Unit) in Malawi?
Your answer should be compact. 4.16e+11. In the year 2010, what is the difference between the Exports (in Local Currency Unit) in Latvia and Exports (in Local Currency Unit) in Malawi?
Your response must be concise. -2.29e+11. In the year 2011, what is the difference between the Exports (in Local Currency Unit) of Guinea-Bissau and Exports (in Local Currency Unit) of Kenya?
Provide a short and direct response. -6.66e+11. In the year 2011, what is the difference between the Exports (in Local Currency Unit) of Guinea-Bissau and Exports (in Local Currency Unit) of Latvia?
Offer a terse response. 1.28e+11. In the year 2011, what is the difference between the Exports (in Local Currency Unit) of Guinea-Bissau and Exports (in Local Currency Unit) of Malawi?
Offer a very short reply. -1.21e+11. In the year 2011, what is the difference between the Exports (in Local Currency Unit) of Kenya and Exports (in Local Currency Unit) of Latvia?
Offer a terse response. 7.94e+11. In the year 2011, what is the difference between the Exports (in Local Currency Unit) of Kenya and Exports (in Local Currency Unit) of Malawi?
Make the answer very short. 5.45e+11. In the year 2011, what is the difference between the Exports (in Local Currency Unit) in Latvia and Exports (in Local Currency Unit) in Malawi?
Give a very brief answer. -2.49e+11. What is the ratio of the Exports (in Local Currency Unit) of Guinea-Bissau in 2006 to that in 2007?
Offer a very short reply. 0.78. What is the ratio of the Exports (in Local Currency Unit) in Kenya in 2006 to that in 2007?
Your answer should be compact. 0.91. What is the ratio of the Exports (in Local Currency Unit) of Latvia in 2006 to that in 2007?
Offer a very short reply. 0.79. What is the ratio of the Exports (in Local Currency Unit) of Malawi in 2006 to that in 2007?
Offer a very short reply. 0.66. What is the ratio of the Exports (in Local Currency Unit) in Guinea-Bissau in 2006 to that in 2008?
Make the answer very short. 0.68. What is the ratio of the Exports (in Local Currency Unit) in Kenya in 2006 to that in 2008?
Your response must be concise. 0.76. What is the ratio of the Exports (in Local Currency Unit) of Latvia in 2006 to that in 2008?
Provide a succinct answer. 0.71. What is the ratio of the Exports (in Local Currency Unit) of Malawi in 2006 to that in 2008?
Provide a short and direct response. 0.57. What is the ratio of the Exports (in Local Currency Unit) of Guinea-Bissau in 2006 to that in 2009?
Your response must be concise. 0.72. What is the ratio of the Exports (in Local Currency Unit) of Kenya in 2006 to that in 2009?
Offer a terse response. 0.75. What is the ratio of the Exports (in Local Currency Unit) of Latvia in 2006 to that in 2009?
Provide a short and direct response. 0.85. What is the ratio of the Exports (in Local Currency Unit) in Malawi in 2006 to that in 2009?
Offer a terse response. 0.55. What is the ratio of the Exports (in Local Currency Unit) in Guinea-Bissau in 2006 to that in 2010?
Provide a short and direct response. 0.63. What is the ratio of the Exports (in Local Currency Unit) of Kenya in 2006 to that in 2010?
Keep it short and to the point. 0.65. What is the ratio of the Exports (in Local Currency Unit) of Latvia in 2006 to that in 2010?
Keep it short and to the point. 0.71. What is the ratio of the Exports (in Local Currency Unit) of Malawi in 2006 to that in 2010?
Provide a short and direct response. 0.4. What is the ratio of the Exports (in Local Currency Unit) of Guinea-Bissau in 2006 to that in 2011?
Keep it short and to the point. 0.38. What is the ratio of the Exports (in Local Currency Unit) of Kenya in 2006 to that in 2011?
Make the answer very short. 0.53. What is the ratio of the Exports (in Local Currency Unit) in Latvia in 2006 to that in 2011?
Your response must be concise. 0.58. What is the ratio of the Exports (in Local Currency Unit) in Malawi in 2006 to that in 2011?
Keep it short and to the point. 0.37. What is the ratio of the Exports (in Local Currency Unit) of Guinea-Bissau in 2007 to that in 2008?
Your answer should be compact. 0.87. What is the ratio of the Exports (in Local Currency Unit) in Kenya in 2007 to that in 2008?
Provide a succinct answer. 0.84. What is the ratio of the Exports (in Local Currency Unit) of Latvia in 2007 to that in 2008?
Offer a very short reply. 0.9. What is the ratio of the Exports (in Local Currency Unit) in Malawi in 2007 to that in 2008?
Ensure brevity in your answer.  0.85. What is the ratio of the Exports (in Local Currency Unit) in Guinea-Bissau in 2007 to that in 2009?
Your response must be concise. 0.92. What is the ratio of the Exports (in Local Currency Unit) in Kenya in 2007 to that in 2009?
Provide a short and direct response. 0.82. What is the ratio of the Exports (in Local Currency Unit) of Latvia in 2007 to that in 2009?
Make the answer very short. 1.08. What is the ratio of the Exports (in Local Currency Unit) in Malawi in 2007 to that in 2009?
Give a very brief answer. 0.83. What is the ratio of the Exports (in Local Currency Unit) of Guinea-Bissau in 2007 to that in 2010?
Give a very brief answer. 0.8. What is the ratio of the Exports (in Local Currency Unit) in Kenya in 2007 to that in 2010?
Your answer should be very brief. 0.72. What is the ratio of the Exports (in Local Currency Unit) of Latvia in 2007 to that in 2010?
Provide a short and direct response. 0.9. What is the ratio of the Exports (in Local Currency Unit) of Malawi in 2007 to that in 2010?
Ensure brevity in your answer.  0.61. What is the ratio of the Exports (in Local Currency Unit) of Guinea-Bissau in 2007 to that in 2011?
Your answer should be very brief. 0.48. What is the ratio of the Exports (in Local Currency Unit) of Kenya in 2007 to that in 2011?
Offer a very short reply. 0.59. What is the ratio of the Exports (in Local Currency Unit) in Latvia in 2007 to that in 2011?
Ensure brevity in your answer.  0.74. What is the ratio of the Exports (in Local Currency Unit) in Malawi in 2007 to that in 2011?
Ensure brevity in your answer.  0.56. What is the ratio of the Exports (in Local Currency Unit) of Guinea-Bissau in 2008 to that in 2009?
Make the answer very short. 1.05. What is the ratio of the Exports (in Local Currency Unit) of Kenya in 2008 to that in 2009?
Ensure brevity in your answer.  0.98. What is the ratio of the Exports (in Local Currency Unit) in Latvia in 2008 to that in 2009?
Offer a very short reply. 1.2. What is the ratio of the Exports (in Local Currency Unit) of Malawi in 2008 to that in 2009?
Provide a short and direct response. 0.97. What is the ratio of the Exports (in Local Currency Unit) in Guinea-Bissau in 2008 to that in 2010?
Provide a succinct answer. 0.92. What is the ratio of the Exports (in Local Currency Unit) in Kenya in 2008 to that in 2010?
Offer a terse response. 0.86. What is the ratio of the Exports (in Local Currency Unit) of Latvia in 2008 to that in 2010?
Provide a succinct answer. 1. What is the ratio of the Exports (in Local Currency Unit) of Malawi in 2008 to that in 2010?
Provide a short and direct response. 0.71. What is the ratio of the Exports (in Local Currency Unit) in Guinea-Bissau in 2008 to that in 2011?
Offer a terse response. 0.55. What is the ratio of the Exports (in Local Currency Unit) of Kenya in 2008 to that in 2011?
Provide a succinct answer. 0.7. What is the ratio of the Exports (in Local Currency Unit) in Latvia in 2008 to that in 2011?
Offer a very short reply. 0.82. What is the ratio of the Exports (in Local Currency Unit) of Malawi in 2008 to that in 2011?
Your answer should be compact. 0.65. What is the ratio of the Exports (in Local Currency Unit) of Guinea-Bissau in 2009 to that in 2010?
Your answer should be compact. 0.87. What is the ratio of the Exports (in Local Currency Unit) of Kenya in 2009 to that in 2010?
Your answer should be very brief. 0.88. What is the ratio of the Exports (in Local Currency Unit) of Latvia in 2009 to that in 2010?
Provide a short and direct response. 0.83. What is the ratio of the Exports (in Local Currency Unit) of Malawi in 2009 to that in 2010?
Make the answer very short. 0.73. What is the ratio of the Exports (in Local Currency Unit) in Guinea-Bissau in 2009 to that in 2011?
Make the answer very short. 0.52. What is the ratio of the Exports (in Local Currency Unit) of Kenya in 2009 to that in 2011?
Your response must be concise. 0.71. What is the ratio of the Exports (in Local Currency Unit) in Latvia in 2009 to that in 2011?
Your answer should be very brief. 0.68. What is the ratio of the Exports (in Local Currency Unit) of Malawi in 2009 to that in 2011?
Keep it short and to the point. 0.67. What is the ratio of the Exports (in Local Currency Unit) of Guinea-Bissau in 2010 to that in 2011?
Your response must be concise. 0.6. What is the ratio of the Exports (in Local Currency Unit) in Kenya in 2010 to that in 2011?
Provide a short and direct response. 0.81. What is the ratio of the Exports (in Local Currency Unit) in Latvia in 2010 to that in 2011?
Offer a very short reply. 0.82. What is the ratio of the Exports (in Local Currency Unit) in Malawi in 2010 to that in 2011?
Offer a terse response. 0.92. What is the difference between the highest and the second highest Exports (in Local Currency Unit) in Guinea-Bissau?
Keep it short and to the point. 5.57e+1. What is the difference between the highest and the second highest Exports (in Local Currency Unit) of Kenya?
Provide a short and direct response. 1.51e+11. What is the difference between the highest and the second highest Exports (in Local Currency Unit) in Latvia?
Your answer should be very brief. 2.11e+09. What is the difference between the highest and the second highest Exports (in Local Currency Unit) in Malawi?
Keep it short and to the point. 2.16e+1. What is the difference between the highest and the lowest Exports (in Local Currency Unit) in Guinea-Bissau?
Provide a short and direct response. 8.69e+1. What is the difference between the highest and the lowest Exports (in Local Currency Unit) of Kenya?
Offer a terse response. 3.78e+11. What is the difference between the highest and the lowest Exports (in Local Currency Unit) of Latvia?
Provide a short and direct response. 4.90e+09. What is the difference between the highest and the lowest Exports (in Local Currency Unit) of Malawi?
Your answer should be compact. 1.64e+11. 